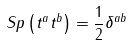<formula> <loc_0><loc_0><loc_500><loc_500>S p \left ( t ^ { a } t ^ { b } \right ) = \frac { 1 } { 2 } \delta ^ { a b } \,</formula> 